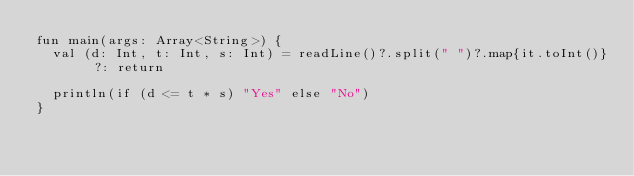<code> <loc_0><loc_0><loc_500><loc_500><_Kotlin_>fun main(args: Array<String>) {
	val (d: Int, t: Int, s: Int) = readLine()?.split(" ")?.map{it.toInt()} ?: return
	
	println(if (d <= t * s) "Yes" else "No")
}</code> 